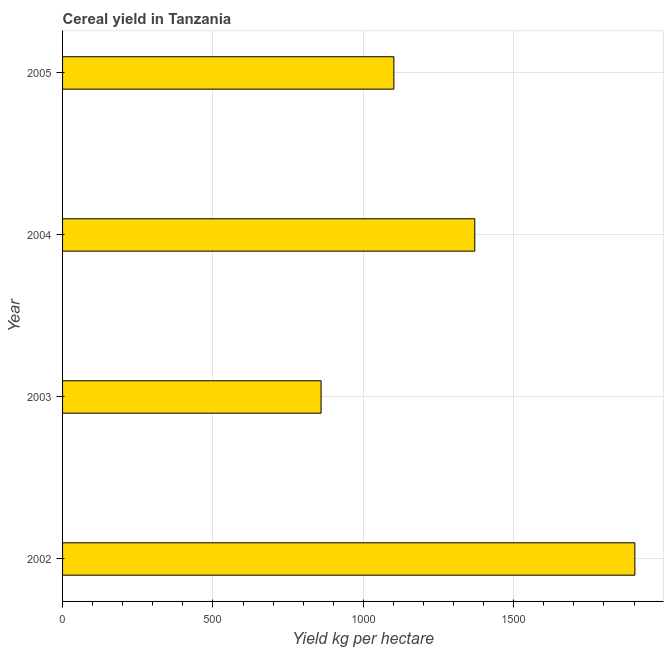Does the graph contain any zero values?
Keep it short and to the point. No. Does the graph contain grids?
Keep it short and to the point. Yes. What is the title of the graph?
Provide a short and direct response. Cereal yield in Tanzania. What is the label or title of the X-axis?
Your answer should be very brief. Yield kg per hectare. What is the cereal yield in 2003?
Keep it short and to the point. 859.55. Across all years, what is the maximum cereal yield?
Provide a succinct answer. 1902.93. Across all years, what is the minimum cereal yield?
Give a very brief answer. 859.55. In which year was the cereal yield minimum?
Provide a succinct answer. 2003. What is the sum of the cereal yield?
Keep it short and to the point. 5234.68. What is the difference between the cereal yield in 2004 and 2005?
Keep it short and to the point. 269. What is the average cereal yield per year?
Your response must be concise. 1308.67. What is the median cereal yield?
Keep it short and to the point. 1236.1. What is the ratio of the cereal yield in 2003 to that in 2004?
Keep it short and to the point. 0.63. Is the cereal yield in 2003 less than that in 2004?
Keep it short and to the point. Yes. What is the difference between the highest and the second highest cereal yield?
Ensure brevity in your answer.  532.33. What is the difference between the highest and the lowest cereal yield?
Your response must be concise. 1043.38. In how many years, is the cereal yield greater than the average cereal yield taken over all years?
Offer a very short reply. 2. Are all the bars in the graph horizontal?
Provide a succinct answer. Yes. How many years are there in the graph?
Your answer should be very brief. 4. What is the difference between two consecutive major ticks on the X-axis?
Your answer should be compact. 500. What is the Yield kg per hectare of 2002?
Provide a succinct answer. 1902.93. What is the Yield kg per hectare in 2003?
Give a very brief answer. 859.55. What is the Yield kg per hectare of 2004?
Provide a short and direct response. 1370.6. What is the Yield kg per hectare of 2005?
Ensure brevity in your answer.  1101.6. What is the difference between the Yield kg per hectare in 2002 and 2003?
Your answer should be compact. 1043.38. What is the difference between the Yield kg per hectare in 2002 and 2004?
Ensure brevity in your answer.  532.33. What is the difference between the Yield kg per hectare in 2002 and 2005?
Your answer should be compact. 801.34. What is the difference between the Yield kg per hectare in 2003 and 2004?
Your response must be concise. -511.05. What is the difference between the Yield kg per hectare in 2003 and 2005?
Keep it short and to the point. -242.04. What is the difference between the Yield kg per hectare in 2004 and 2005?
Make the answer very short. 269. What is the ratio of the Yield kg per hectare in 2002 to that in 2003?
Provide a short and direct response. 2.21. What is the ratio of the Yield kg per hectare in 2002 to that in 2004?
Keep it short and to the point. 1.39. What is the ratio of the Yield kg per hectare in 2002 to that in 2005?
Provide a succinct answer. 1.73. What is the ratio of the Yield kg per hectare in 2003 to that in 2004?
Keep it short and to the point. 0.63. What is the ratio of the Yield kg per hectare in 2003 to that in 2005?
Ensure brevity in your answer.  0.78. What is the ratio of the Yield kg per hectare in 2004 to that in 2005?
Provide a succinct answer. 1.24. 